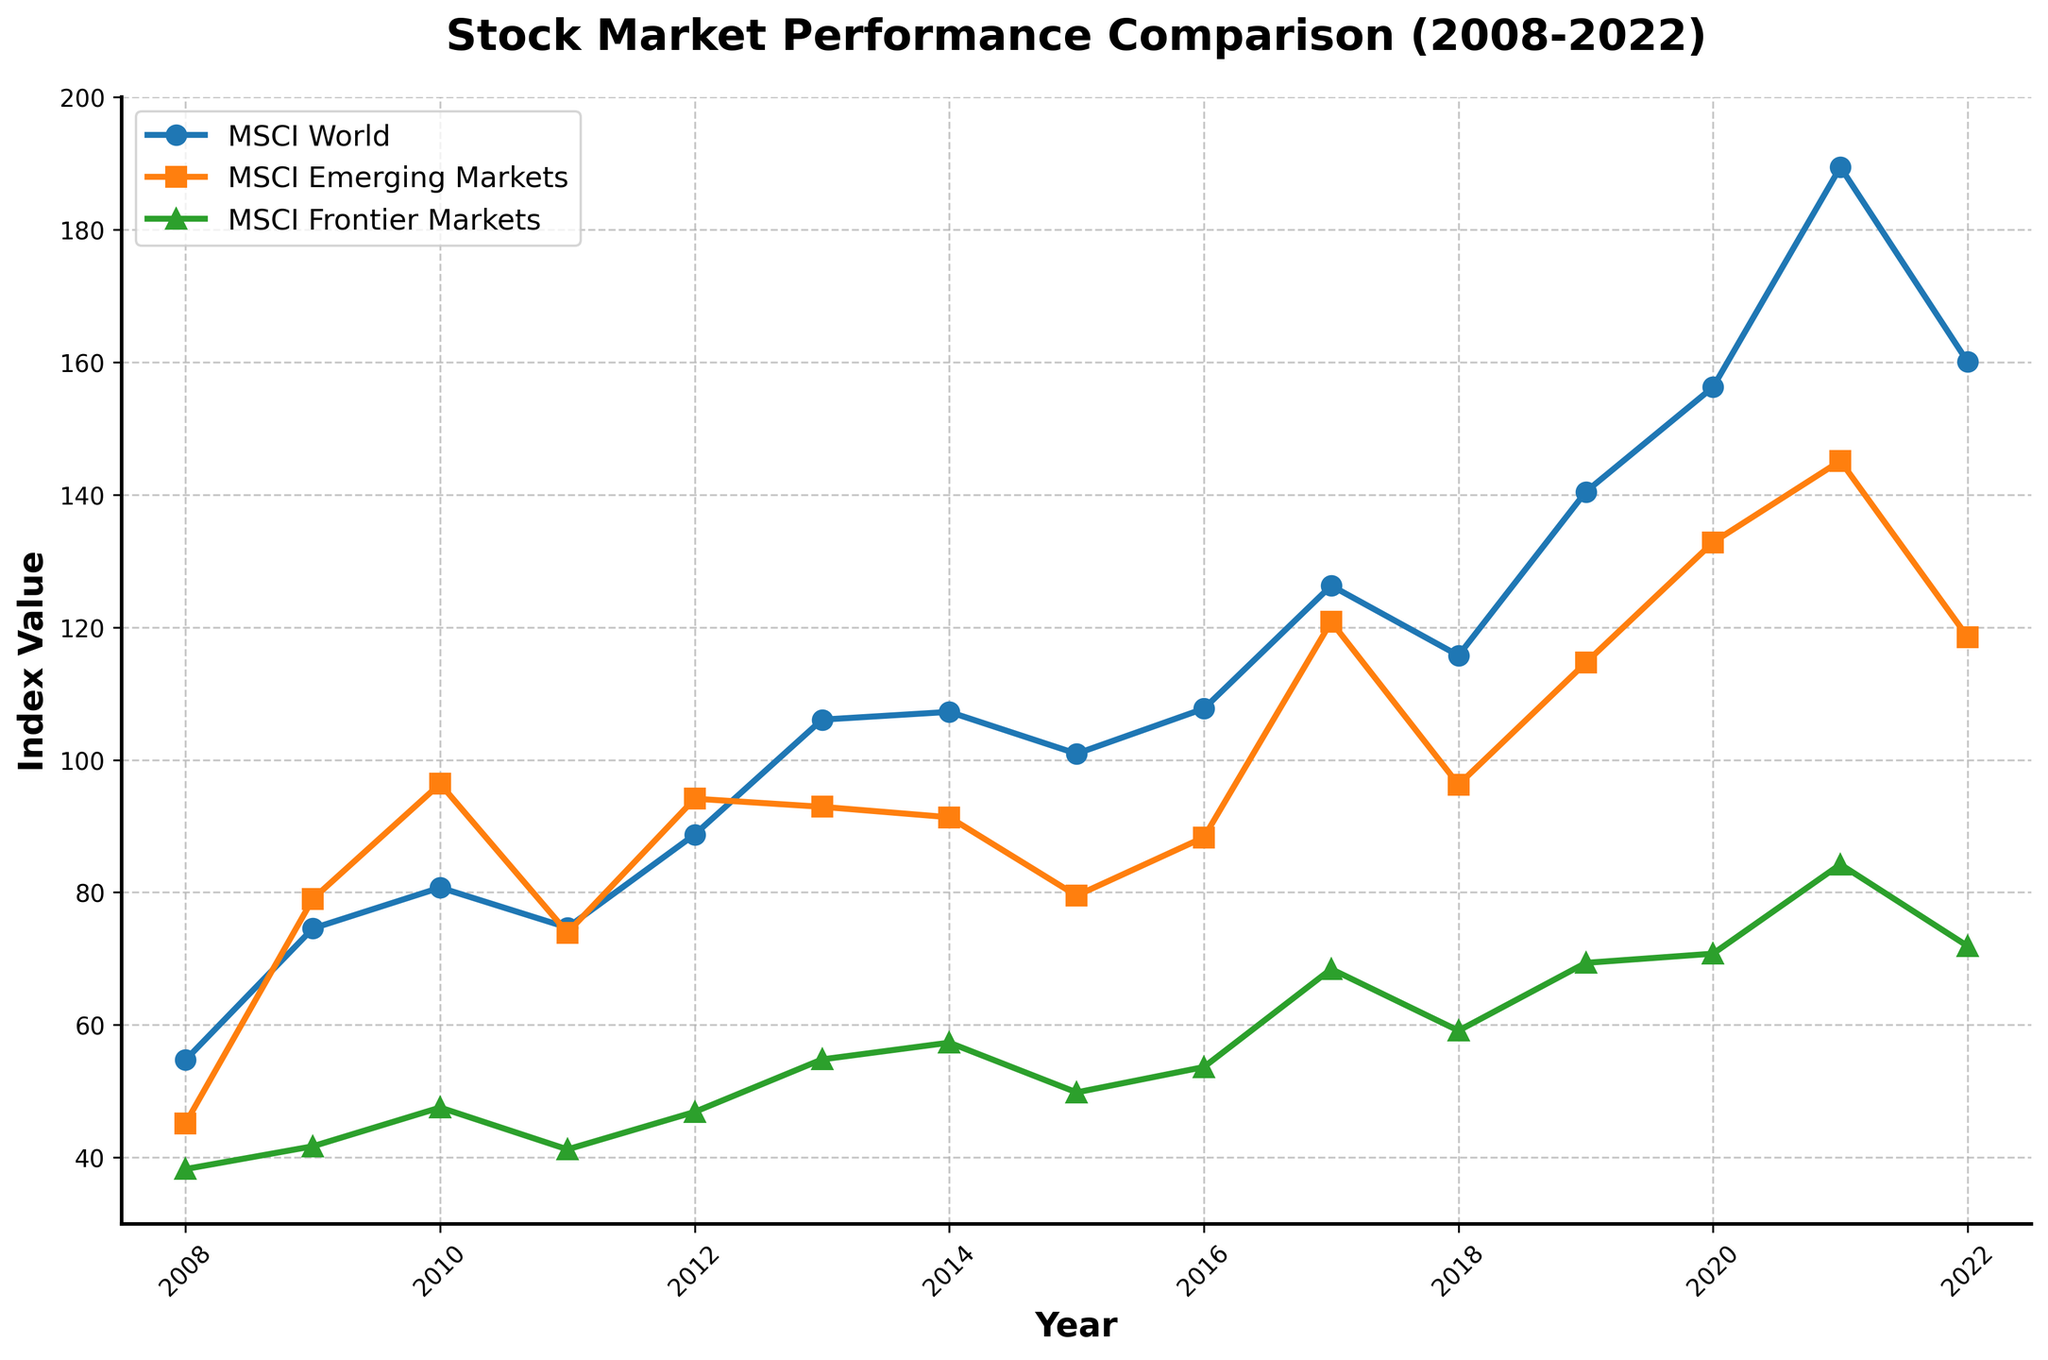What is the overall trend of the MSCI World index from 2008 to 2022? Viewing the MSCI World index in the figure, we see a general upward trend starting from 54.72 in 2008 and rising to 160.06 in 2022, with some fluctuations in between.
Answer: Upward trend In which year did MSCI Emerging Markets have its highest value, and what was the value? By examining the line representing MSCI Emerging Markets, the highest value is seen in 2010, where the index value is 96.39.
Answer: 2010 with a value of 96.39 How does the 2021 value of MSCI Frontier Markets compare to its 2022 value? The MSCI Frontier Markets value in 2021 is 84.23, and in 2022 it's 71.89. Thus, the 2022 value is lower than in 2021.
Answer: 2022 is lower than 2021 What is the difference in the MSCI World index value between 2019 and 2020? The MSCI World index value was 140.46 in 2019 and increased to 156.26 in 2020. The difference is 156.26 - 140.46 = 15.8.
Answer: 15.8 During which year did all three indices (MSCI World, MSCI Emerging Markets, MSCI Frontier Markets) experience a drop in value from the previous year? By analyzing the trends, all three indices drop in 2011 from their 2010 values: MSCI World from 80.72 to 74.69, MSCI Emerging Markets from 96.39 to 73.92, and MSCI Frontier Markets from 47.53 to 41.21.
Answer: 2011 What is the visual attribute (color and marker type) used for the MSCI Frontier Markets index? The MSCI Frontier Markets index is represented using a green color and a triangular marker on the line chart.
Answer: Green color and triangular marker Calculate the average MSCI Emerging Markets index value over the last 15 years. Sum the MSCI Emerging Markets values from 2008 to 2022: 45.16 + 79.02 + 96.39 + 73.92 + 94.14 + 92.91 + 91.34 + 79.51 + 88.31 + 120.85 + 96.25 + 114.66 + 132.84 + 145.12 + 118.53 = 1468.95. Divide by 15 years: 1468.95 / 15 = 97.93.
Answer: 97.93 How did the MSCI World index perform in 2011 compared to 2010, and what might this indicate about that period? The MSCI World index decreased from 80.72 in 2010 to 74.69 in 2011. This indicates a decline, possibly due to market volatility or economic downturns during that period.
Answer: Decreased from 80.72 to 74.69 What is the cumulative increase in the MSCI Frontier Markets index from 2008 to 2022? The MSCI Frontier Markets index starts at 38.24 in 2008 and ends at 71.89 in 2022. The cumulative increase is 71.89 - 38.24 = 33.65.
Answer: 33.65 Identify the year when the MSCI World index first surpassed the value of 100, and what was the exact value that year? In 2013, the MSCI World index first surpassed 100, with a value of 106.07.
Answer: 2013 with a value of 106.07 